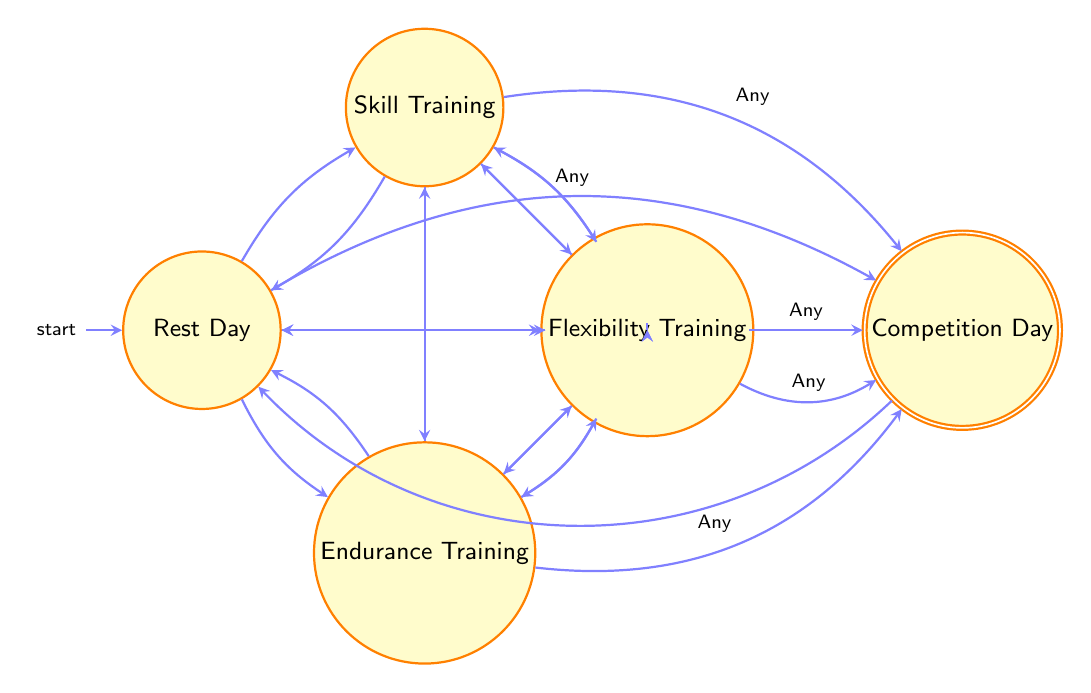What are the states in the diagram? The diagram contains the following states: Rest Day, Skill Training, Endurance Training, Strength Training, Flexibility Training, and Competition Day.
Answer: Rest Day, Skill Training, Endurance Training, Strength Training, Flexibility Training, Competition Day How many states are there in total? There are a total of six states represented in the diagram: Rest Day, Skill Training, Endurance Training, Strength Training, Flexibility Training, and Competition Day.
Answer: 6 What state comes after Competition Day? According to the transitions in the diagram, Competition Day transitions to Rest Day.
Answer: Rest Day Can you move from Rest Day to any other state? Yes, the diagram shows direct transitions from Rest Day to Skill Training, Endurance Training, Strength Training, and Flexibility Training.
Answer: Yes Which state does Skill Training transition to after a session? Skill Training can transition back to Rest Day or to Endurance Training, Strength Training, or Flexibility Training, as indicated by the transitions.
Answer: Rest Day, Endurance Training, Strength Training, Flexibility Training What is the final state that ends the training schedule? The training schedule ends in Rest Day after participating in Competition Day, as shown by the transition from Competition Day back to Rest Day.
Answer: Rest Day How do you reach Competition Day from any state? In the diagram, any state can transition to Competition Day, which indicates that every state has the potential to lead to Competition Day directly.
Answer: Any state How does Flexibility Training relate to Strength Training? Flexibility Training can transition directly to Strength Training, indicating a relationship where Flexibility Training is a precursor or option before moving to Strength Training.
Answer: Flexibility Training transitions to Strength Training 